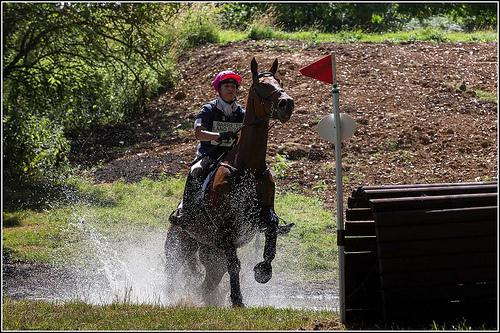Question: what color helmet is the rider wearing?
Choices:
A. Red.
B. Black.
C. Green.
D. Blue.
Answer with the letter. Answer: A Question: what are they riding through?
Choices:
A. Mud.
B. Water.
C. Rain.
D. Snow.
Answer with the letter. Answer: B Question: where are they riding?
Choices:
A. In a field.
B. On a course.
C. In the stream.
D. On the mountain.
Answer with the letter. Answer: B Question: what is the person doing?
Choices:
A. Riding a bike.
B. Riding a scooter.
C. Riding a horse.
D. Driving a car.
Answer with the letter. Answer: C Question: how is the man crossing the water?
Choices:
A. On a bike.
B. On a bridge.
C. On a donkey.
D. On horseback.
Answer with the letter. Answer: D Question: who is on the horse?
Choices:
A. A woman.
B. A boy.
C. A man.
D. A girl.
Answer with the letter. Answer: C Question: when does the picture take place?
Choices:
A. During the night.
B. During a hurricane.
C. Before the sunset.
D. During the day.
Answer with the letter. Answer: D 